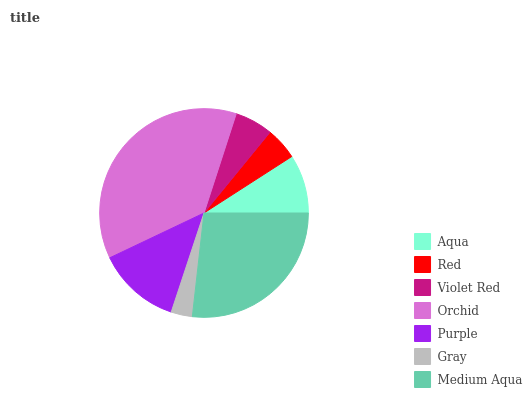Is Gray the minimum?
Answer yes or no. Yes. Is Orchid the maximum?
Answer yes or no. Yes. Is Red the minimum?
Answer yes or no. No. Is Red the maximum?
Answer yes or no. No. Is Aqua greater than Red?
Answer yes or no. Yes. Is Red less than Aqua?
Answer yes or no. Yes. Is Red greater than Aqua?
Answer yes or no. No. Is Aqua less than Red?
Answer yes or no. No. Is Aqua the high median?
Answer yes or no. Yes. Is Aqua the low median?
Answer yes or no. Yes. Is Red the high median?
Answer yes or no. No. Is Purple the low median?
Answer yes or no. No. 